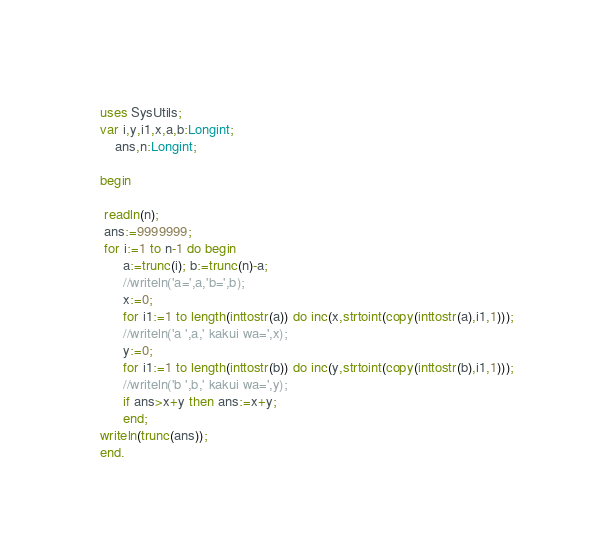<code> <loc_0><loc_0><loc_500><loc_500><_Pascal_>
uses SysUtils;
var i,y,i1,x,a,b:Longint;
    ans,n:Longint;

begin
 
 readln(n);
 ans:=9999999;
 for i:=1 to n-1 do begin
      a:=trunc(i); b:=trunc(n)-a;
      //writeln('a=',a,'b=',b);
      x:=0;
      for i1:=1 to length(inttostr(a)) do inc(x,strtoint(copy(inttostr(a),i1,1)));
      //writeln('a ',a,' kakui wa=',x);
      y:=0;
      for i1:=1 to length(inttostr(b)) do inc(y,strtoint(copy(inttostr(b),i1,1)));
      //writeln('b ',b,' kakui wa=',y);
      if ans>x+y then ans:=x+y;
      end;
writeln(trunc(ans));
end.</code> 